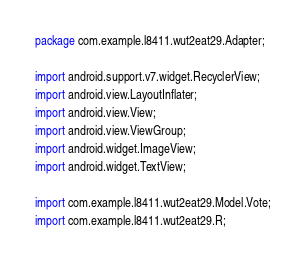<code> <loc_0><loc_0><loc_500><loc_500><_Java_>package com.example.l8411.wut2eat29.Adapter;

import android.support.v7.widget.RecyclerView;
import android.view.LayoutInflater;
import android.view.View;
import android.view.ViewGroup;
import android.widget.ImageView;
import android.widget.TextView;

import com.example.l8411.wut2eat29.Model.Vote;
import com.example.l8411.wut2eat29.R;</code> 